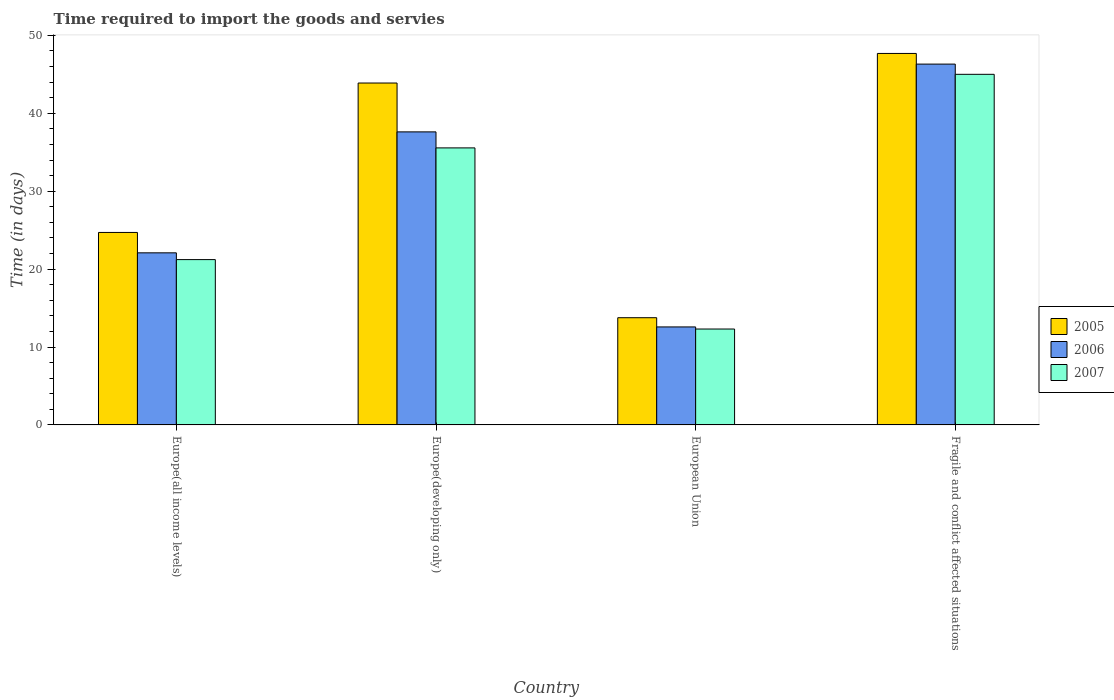How many different coloured bars are there?
Your answer should be compact. 3. How many groups of bars are there?
Provide a short and direct response. 4. Are the number of bars on each tick of the X-axis equal?
Keep it short and to the point. Yes. How many bars are there on the 4th tick from the right?
Offer a terse response. 3. What is the label of the 2nd group of bars from the left?
Offer a very short reply. Europe(developing only). In how many cases, is the number of bars for a given country not equal to the number of legend labels?
Provide a succinct answer. 0. What is the number of days required to import the goods and services in 2006 in Europe(all income levels)?
Make the answer very short. 22.09. Across all countries, what is the maximum number of days required to import the goods and services in 2006?
Offer a terse response. 46.31. Across all countries, what is the minimum number of days required to import the goods and services in 2006?
Your response must be concise. 12.58. In which country was the number of days required to import the goods and services in 2005 maximum?
Your response must be concise. Fragile and conflict affected situations. What is the total number of days required to import the goods and services in 2007 in the graph?
Your answer should be compact. 114.08. What is the difference between the number of days required to import the goods and services in 2005 in European Union and that in Fragile and conflict affected situations?
Give a very brief answer. -33.92. What is the difference between the number of days required to import the goods and services in 2005 in Europe(developing only) and the number of days required to import the goods and services in 2007 in Europe(all income levels)?
Make the answer very short. 22.66. What is the average number of days required to import the goods and services in 2006 per country?
Provide a succinct answer. 29.65. What is the difference between the number of days required to import the goods and services of/in 2005 and number of days required to import the goods and services of/in 2007 in Fragile and conflict affected situations?
Give a very brief answer. 2.68. In how many countries, is the number of days required to import the goods and services in 2005 greater than 38 days?
Give a very brief answer. 2. What is the ratio of the number of days required to import the goods and services in 2006 in Europe(developing only) to that in Fragile and conflict affected situations?
Your answer should be compact. 0.81. Is the number of days required to import the goods and services in 2005 in Europe(all income levels) less than that in European Union?
Offer a terse response. No. Is the difference between the number of days required to import the goods and services in 2005 in Europe(developing only) and Fragile and conflict affected situations greater than the difference between the number of days required to import the goods and services in 2007 in Europe(developing only) and Fragile and conflict affected situations?
Your answer should be compact. Yes. What is the difference between the highest and the second highest number of days required to import the goods and services in 2006?
Your answer should be very brief. -8.7. What is the difference between the highest and the lowest number of days required to import the goods and services in 2005?
Give a very brief answer. 33.92. What does the 2nd bar from the left in Europe(developing only) represents?
Your answer should be very brief. 2006. What does the 2nd bar from the right in Fragile and conflict affected situations represents?
Offer a very short reply. 2006. Is it the case that in every country, the sum of the number of days required to import the goods and services in 2005 and number of days required to import the goods and services in 2006 is greater than the number of days required to import the goods and services in 2007?
Your response must be concise. Yes. How many bars are there?
Keep it short and to the point. 12. Are all the bars in the graph horizontal?
Provide a short and direct response. No. What is the difference between two consecutive major ticks on the Y-axis?
Make the answer very short. 10. Does the graph contain any zero values?
Make the answer very short. No. How many legend labels are there?
Your response must be concise. 3. What is the title of the graph?
Your answer should be very brief. Time required to import the goods and servies. What is the label or title of the Y-axis?
Your answer should be very brief. Time (in days). What is the Time (in days) in 2005 in Europe(all income levels)?
Your response must be concise. 24.7. What is the Time (in days) in 2006 in Europe(all income levels)?
Keep it short and to the point. 22.09. What is the Time (in days) of 2007 in Europe(all income levels)?
Provide a succinct answer. 21.22. What is the Time (in days) of 2005 in Europe(developing only)?
Offer a very short reply. 43.88. What is the Time (in days) of 2006 in Europe(developing only)?
Your answer should be very brief. 37.61. What is the Time (in days) in 2007 in Europe(developing only)?
Provide a short and direct response. 35.56. What is the Time (in days) in 2005 in European Union?
Keep it short and to the point. 13.76. What is the Time (in days) in 2006 in European Union?
Provide a short and direct response. 12.58. What is the Time (in days) in 2007 in European Union?
Offer a very short reply. 12.31. What is the Time (in days) of 2005 in Fragile and conflict affected situations?
Keep it short and to the point. 47.68. What is the Time (in days) of 2006 in Fragile and conflict affected situations?
Provide a short and direct response. 46.31. What is the Time (in days) of 2007 in Fragile and conflict affected situations?
Offer a very short reply. 45. Across all countries, what is the maximum Time (in days) in 2005?
Give a very brief answer. 47.68. Across all countries, what is the maximum Time (in days) in 2006?
Provide a succinct answer. 46.31. Across all countries, what is the minimum Time (in days) in 2005?
Make the answer very short. 13.76. Across all countries, what is the minimum Time (in days) in 2006?
Provide a succinct answer. 12.58. Across all countries, what is the minimum Time (in days) in 2007?
Your response must be concise. 12.31. What is the total Time (in days) in 2005 in the graph?
Offer a terse response. 130.03. What is the total Time (in days) in 2006 in the graph?
Provide a succinct answer. 118.59. What is the total Time (in days) of 2007 in the graph?
Your answer should be very brief. 114.08. What is the difference between the Time (in days) in 2005 in Europe(all income levels) and that in Europe(developing only)?
Ensure brevity in your answer.  -19.18. What is the difference between the Time (in days) in 2006 in Europe(all income levels) and that in Europe(developing only)?
Make the answer very short. -15.52. What is the difference between the Time (in days) of 2007 in Europe(all income levels) and that in Europe(developing only)?
Your answer should be compact. -14.34. What is the difference between the Time (in days) in 2005 in Europe(all income levels) and that in European Union?
Give a very brief answer. 10.94. What is the difference between the Time (in days) of 2006 in Europe(all income levels) and that in European Union?
Keep it short and to the point. 9.51. What is the difference between the Time (in days) of 2007 in Europe(all income levels) and that in European Union?
Your answer should be very brief. 8.91. What is the difference between the Time (in days) of 2005 in Europe(all income levels) and that in Fragile and conflict affected situations?
Offer a terse response. -22.97. What is the difference between the Time (in days) of 2006 in Europe(all income levels) and that in Fragile and conflict affected situations?
Your response must be concise. -24.22. What is the difference between the Time (in days) of 2007 in Europe(all income levels) and that in Fragile and conflict affected situations?
Keep it short and to the point. -23.78. What is the difference between the Time (in days) in 2005 in Europe(developing only) and that in European Union?
Provide a short and direct response. 30.12. What is the difference between the Time (in days) in 2006 in Europe(developing only) and that in European Union?
Offer a terse response. 25.03. What is the difference between the Time (in days) of 2007 in Europe(developing only) and that in European Union?
Your answer should be very brief. 23.25. What is the difference between the Time (in days) of 2005 in Europe(developing only) and that in Fragile and conflict affected situations?
Keep it short and to the point. -3.8. What is the difference between the Time (in days) in 2006 in Europe(developing only) and that in Fragile and conflict affected situations?
Provide a succinct answer. -8.7. What is the difference between the Time (in days) in 2007 in Europe(developing only) and that in Fragile and conflict affected situations?
Provide a succinct answer. -9.44. What is the difference between the Time (in days) of 2005 in European Union and that in Fragile and conflict affected situations?
Your answer should be compact. -33.92. What is the difference between the Time (in days) in 2006 in European Union and that in Fragile and conflict affected situations?
Keep it short and to the point. -33.73. What is the difference between the Time (in days) in 2007 in European Union and that in Fragile and conflict affected situations?
Provide a short and direct response. -32.69. What is the difference between the Time (in days) of 2005 in Europe(all income levels) and the Time (in days) of 2006 in Europe(developing only)?
Provide a succinct answer. -12.91. What is the difference between the Time (in days) of 2005 in Europe(all income levels) and the Time (in days) of 2007 in Europe(developing only)?
Provide a short and direct response. -10.85. What is the difference between the Time (in days) in 2006 in Europe(all income levels) and the Time (in days) in 2007 in Europe(developing only)?
Offer a terse response. -13.47. What is the difference between the Time (in days) in 2005 in Europe(all income levels) and the Time (in days) in 2006 in European Union?
Your response must be concise. 12.13. What is the difference between the Time (in days) in 2005 in Europe(all income levels) and the Time (in days) in 2007 in European Union?
Ensure brevity in your answer.  12.4. What is the difference between the Time (in days) of 2006 in Europe(all income levels) and the Time (in days) of 2007 in European Union?
Your response must be concise. 9.78. What is the difference between the Time (in days) in 2005 in Europe(all income levels) and the Time (in days) in 2006 in Fragile and conflict affected situations?
Provide a succinct answer. -21.61. What is the difference between the Time (in days) of 2005 in Europe(all income levels) and the Time (in days) of 2007 in Fragile and conflict affected situations?
Offer a very short reply. -20.3. What is the difference between the Time (in days) in 2006 in Europe(all income levels) and the Time (in days) in 2007 in Fragile and conflict affected situations?
Your answer should be compact. -22.91. What is the difference between the Time (in days) in 2005 in Europe(developing only) and the Time (in days) in 2006 in European Union?
Your response must be concise. 31.31. What is the difference between the Time (in days) in 2005 in Europe(developing only) and the Time (in days) in 2007 in European Union?
Your answer should be very brief. 31.57. What is the difference between the Time (in days) in 2006 in Europe(developing only) and the Time (in days) in 2007 in European Union?
Offer a very short reply. 25.3. What is the difference between the Time (in days) of 2005 in Europe(developing only) and the Time (in days) of 2006 in Fragile and conflict affected situations?
Your answer should be compact. -2.43. What is the difference between the Time (in days) of 2005 in Europe(developing only) and the Time (in days) of 2007 in Fragile and conflict affected situations?
Give a very brief answer. -1.12. What is the difference between the Time (in days) of 2006 in Europe(developing only) and the Time (in days) of 2007 in Fragile and conflict affected situations?
Your response must be concise. -7.39. What is the difference between the Time (in days) of 2005 in European Union and the Time (in days) of 2006 in Fragile and conflict affected situations?
Your answer should be very brief. -32.55. What is the difference between the Time (in days) of 2005 in European Union and the Time (in days) of 2007 in Fragile and conflict affected situations?
Your answer should be very brief. -31.24. What is the difference between the Time (in days) of 2006 in European Union and the Time (in days) of 2007 in Fragile and conflict affected situations?
Give a very brief answer. -32.42. What is the average Time (in days) of 2005 per country?
Offer a very short reply. 32.51. What is the average Time (in days) in 2006 per country?
Offer a very short reply. 29.65. What is the average Time (in days) in 2007 per country?
Your answer should be compact. 28.52. What is the difference between the Time (in days) of 2005 and Time (in days) of 2006 in Europe(all income levels)?
Your answer should be compact. 2.62. What is the difference between the Time (in days) of 2005 and Time (in days) of 2007 in Europe(all income levels)?
Make the answer very short. 3.49. What is the difference between the Time (in days) of 2006 and Time (in days) of 2007 in Europe(all income levels)?
Your answer should be very brief. 0.87. What is the difference between the Time (in days) of 2005 and Time (in days) of 2006 in Europe(developing only)?
Ensure brevity in your answer.  6.27. What is the difference between the Time (in days) in 2005 and Time (in days) in 2007 in Europe(developing only)?
Make the answer very short. 8.33. What is the difference between the Time (in days) of 2006 and Time (in days) of 2007 in Europe(developing only)?
Your answer should be compact. 2.06. What is the difference between the Time (in days) of 2005 and Time (in days) of 2006 in European Union?
Provide a succinct answer. 1.18. What is the difference between the Time (in days) of 2005 and Time (in days) of 2007 in European Union?
Make the answer very short. 1.45. What is the difference between the Time (in days) of 2006 and Time (in days) of 2007 in European Union?
Provide a succinct answer. 0.27. What is the difference between the Time (in days) in 2005 and Time (in days) in 2006 in Fragile and conflict affected situations?
Your answer should be very brief. 1.37. What is the difference between the Time (in days) in 2005 and Time (in days) in 2007 in Fragile and conflict affected situations?
Keep it short and to the point. 2.68. What is the difference between the Time (in days) in 2006 and Time (in days) in 2007 in Fragile and conflict affected situations?
Offer a terse response. 1.31. What is the ratio of the Time (in days) of 2005 in Europe(all income levels) to that in Europe(developing only)?
Your answer should be compact. 0.56. What is the ratio of the Time (in days) of 2006 in Europe(all income levels) to that in Europe(developing only)?
Give a very brief answer. 0.59. What is the ratio of the Time (in days) of 2007 in Europe(all income levels) to that in Europe(developing only)?
Provide a succinct answer. 0.6. What is the ratio of the Time (in days) in 2005 in Europe(all income levels) to that in European Union?
Provide a short and direct response. 1.8. What is the ratio of the Time (in days) of 2006 in Europe(all income levels) to that in European Union?
Ensure brevity in your answer.  1.76. What is the ratio of the Time (in days) of 2007 in Europe(all income levels) to that in European Union?
Ensure brevity in your answer.  1.72. What is the ratio of the Time (in days) in 2005 in Europe(all income levels) to that in Fragile and conflict affected situations?
Your answer should be compact. 0.52. What is the ratio of the Time (in days) in 2006 in Europe(all income levels) to that in Fragile and conflict affected situations?
Your answer should be compact. 0.48. What is the ratio of the Time (in days) in 2007 in Europe(all income levels) to that in Fragile and conflict affected situations?
Give a very brief answer. 0.47. What is the ratio of the Time (in days) of 2005 in Europe(developing only) to that in European Union?
Offer a very short reply. 3.19. What is the ratio of the Time (in days) in 2006 in Europe(developing only) to that in European Union?
Provide a succinct answer. 2.99. What is the ratio of the Time (in days) in 2007 in Europe(developing only) to that in European Union?
Your answer should be very brief. 2.89. What is the ratio of the Time (in days) of 2005 in Europe(developing only) to that in Fragile and conflict affected situations?
Keep it short and to the point. 0.92. What is the ratio of the Time (in days) of 2006 in Europe(developing only) to that in Fragile and conflict affected situations?
Keep it short and to the point. 0.81. What is the ratio of the Time (in days) of 2007 in Europe(developing only) to that in Fragile and conflict affected situations?
Make the answer very short. 0.79. What is the ratio of the Time (in days) in 2005 in European Union to that in Fragile and conflict affected situations?
Your answer should be very brief. 0.29. What is the ratio of the Time (in days) in 2006 in European Union to that in Fragile and conflict affected situations?
Your response must be concise. 0.27. What is the ratio of the Time (in days) of 2007 in European Union to that in Fragile and conflict affected situations?
Make the answer very short. 0.27. What is the difference between the highest and the second highest Time (in days) in 2005?
Offer a very short reply. 3.8. What is the difference between the highest and the second highest Time (in days) in 2006?
Offer a terse response. 8.7. What is the difference between the highest and the second highest Time (in days) in 2007?
Your response must be concise. 9.44. What is the difference between the highest and the lowest Time (in days) of 2005?
Offer a very short reply. 33.92. What is the difference between the highest and the lowest Time (in days) of 2006?
Your answer should be very brief. 33.73. What is the difference between the highest and the lowest Time (in days) of 2007?
Your answer should be compact. 32.69. 